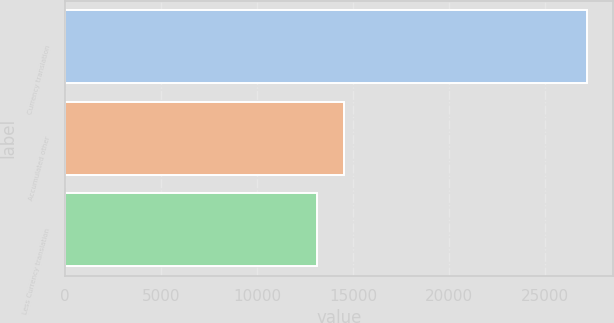<chart> <loc_0><loc_0><loc_500><loc_500><bar_chart><fcel>Currency translation<fcel>Accumulated other<fcel>Less Currency translation<nl><fcel>27167<fcel>14547.2<fcel>13145<nl></chart> 